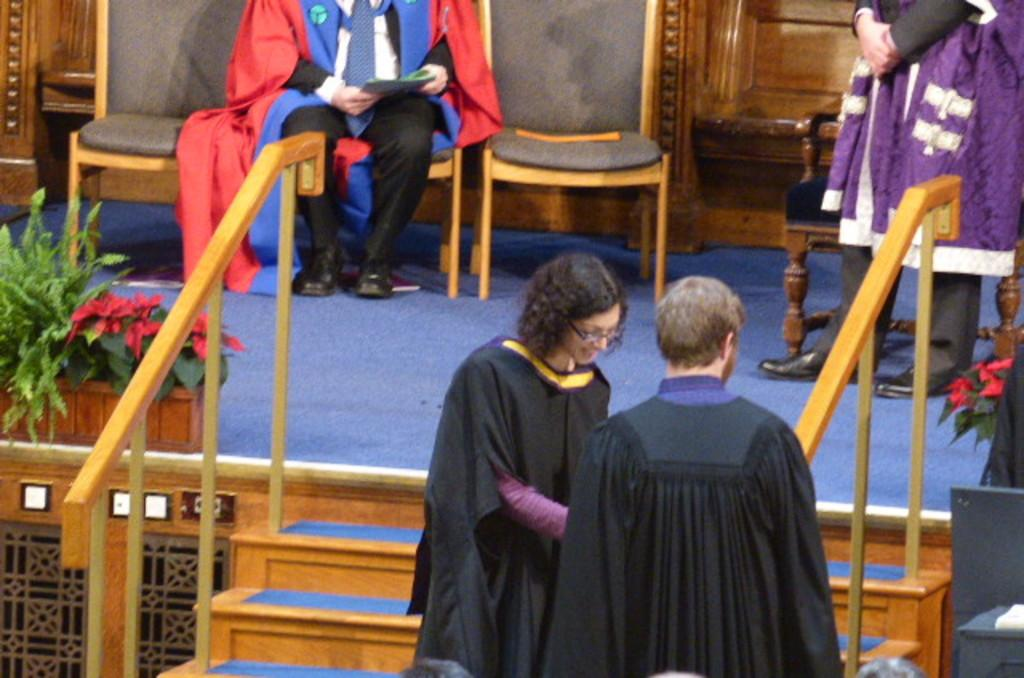What type of structure is present in the image? There are stairs in the image. What type of vegetation can be seen in the image? There are plants and flowers in the image. Who or what is present in the image? There are people in the image. What type of furniture is visible in the image? There are chairs in the image. What degree does the plant have in the image? There is no indication of a degree in the image, as it features stairs, plants, flowers, people, and chairs. What is the top of the plant like in the image? There is no specific detail about the top of the plant in the image, as it only shows plants and flowers in general. 